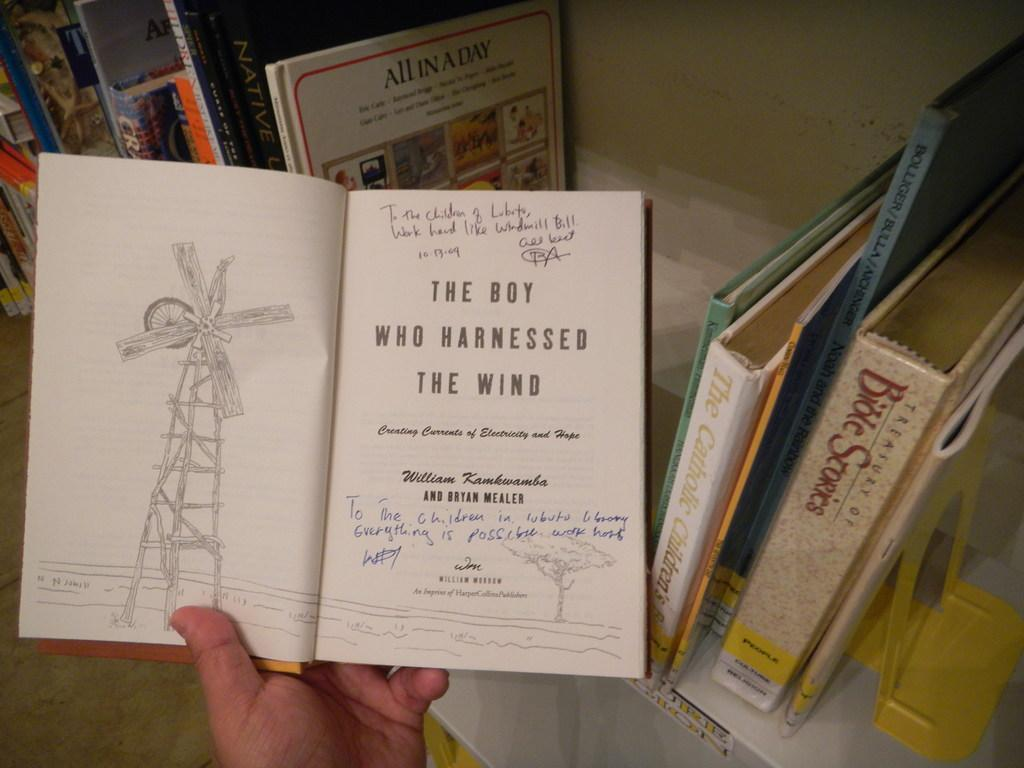<image>
Relay a brief, clear account of the picture shown. a book called The Boy who Harnessed the Wind 